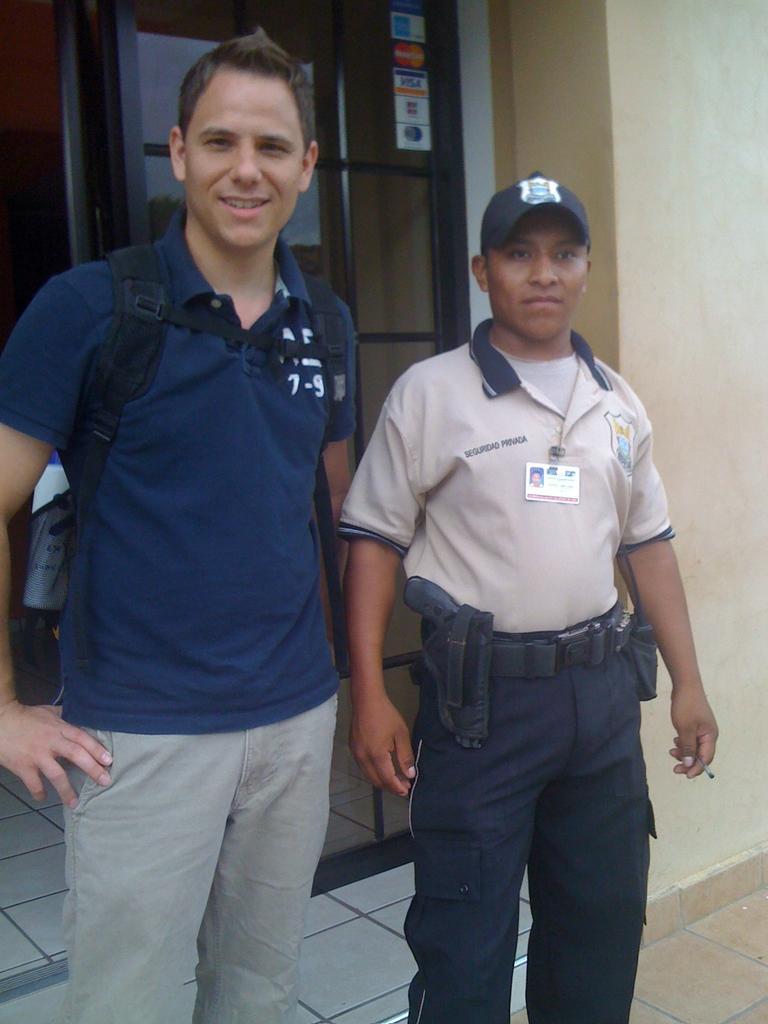Describe this image in one or two sentences. In this picture there is a person with blue t-shirt is standing and smiling and there is a person standing. At the back there is a building and there are stickers on the door. At the bottom there are tiles. There is a reflection of sky and tree on the door. 